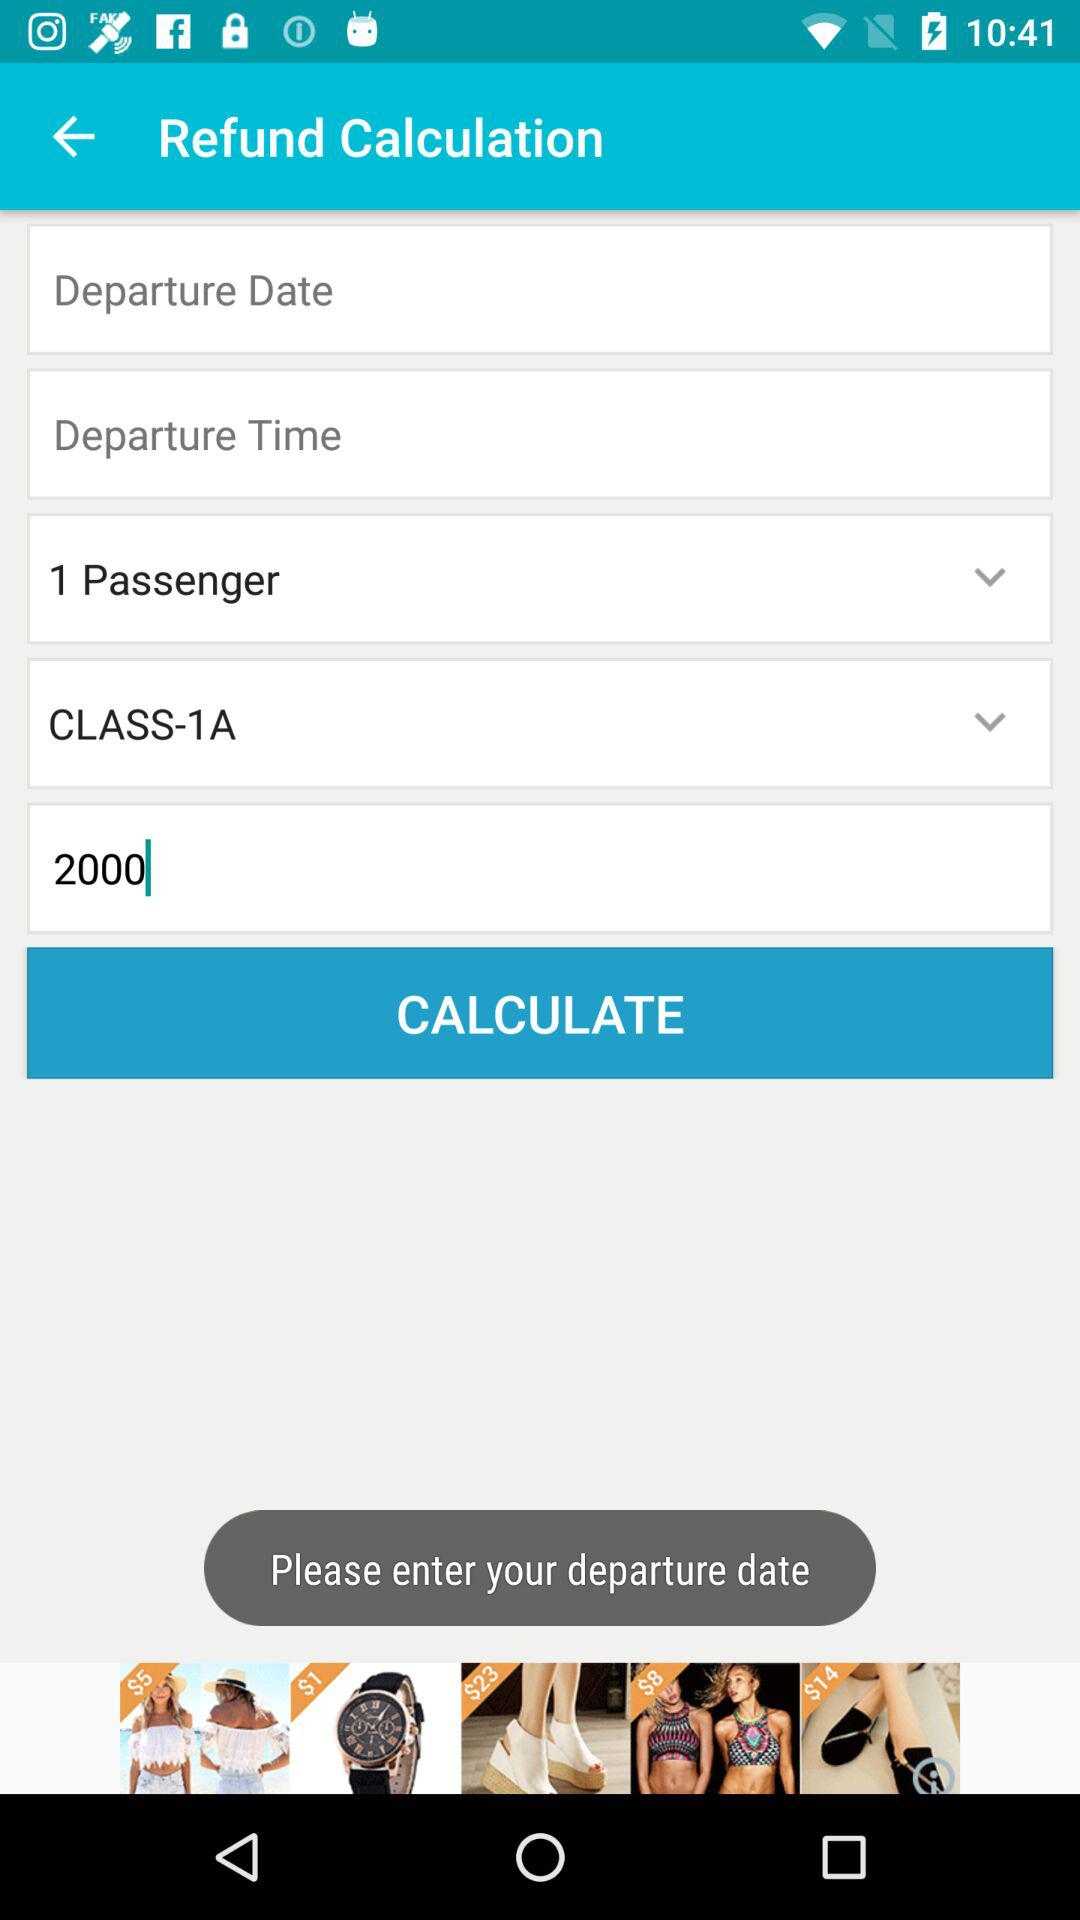Which date is selected for the departure?
When the provided information is insufficient, respond with <no answer>. <no answer> 